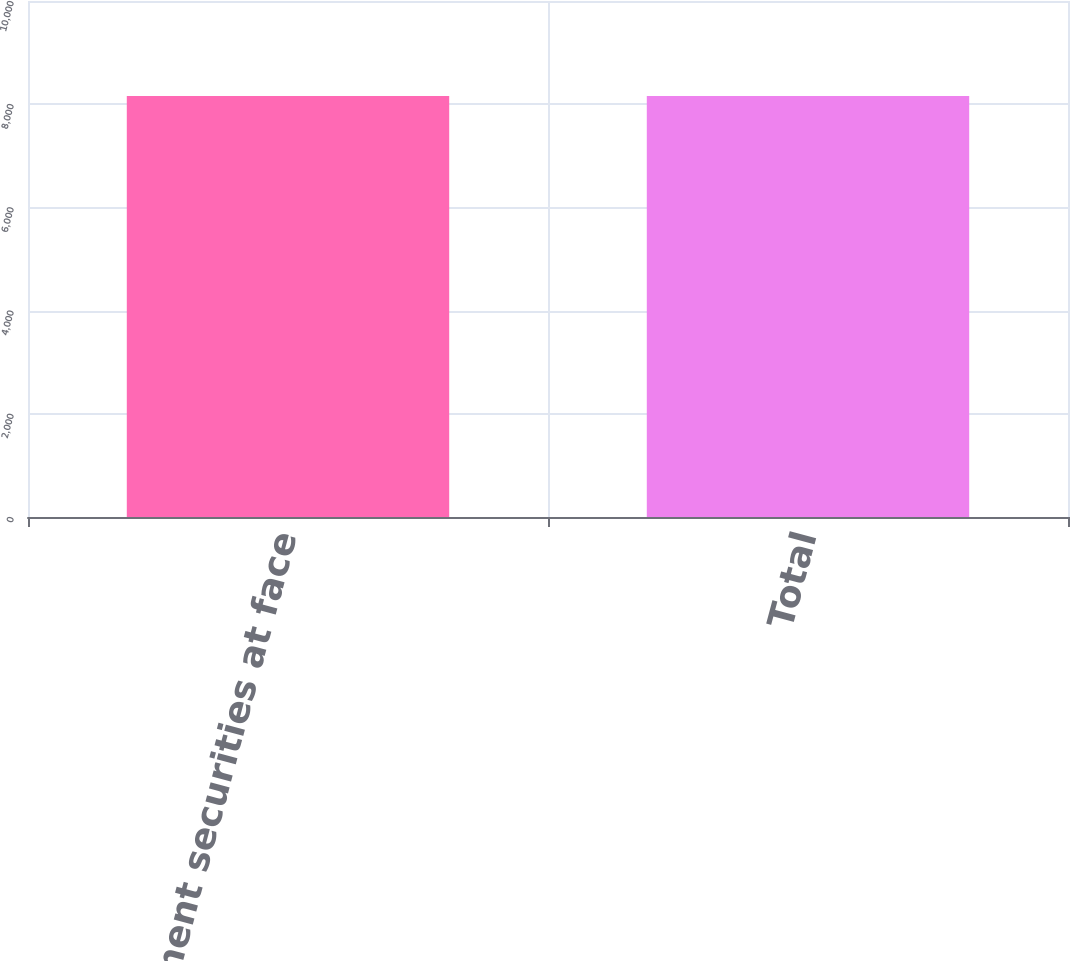Convert chart to OTSL. <chart><loc_0><loc_0><loc_500><loc_500><bar_chart><fcel>Government securities at face<fcel>Total<nl><fcel>8161<fcel>8161.1<nl></chart> 